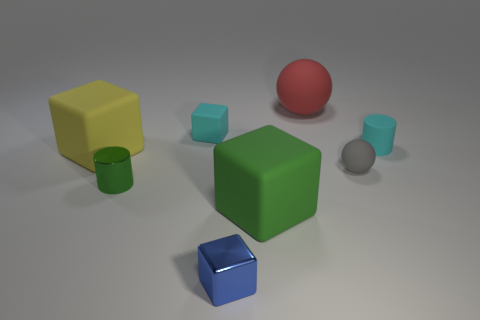Do the big matte sphere and the small metal cylinder have the same color?
Give a very brief answer. No. There is a yellow thing that is made of the same material as the big red thing; what shape is it?
Your answer should be very brief. Cube. There is a tiny matte object in front of the yellow cube; is its shape the same as the green matte object?
Your answer should be very brief. No. How many gray things are metal objects or metallic cubes?
Your answer should be very brief. 0. Are there an equal number of gray things that are left of the small shiny block and small metal things that are on the right side of the green matte cube?
Offer a very short reply. Yes. There is a matte block that is to the right of the small cyan rubber object left of the big rubber thing that is in front of the green cylinder; what color is it?
Your response must be concise. Green. Is there any other thing of the same color as the rubber cylinder?
Ensure brevity in your answer.  Yes. There is a tiny rubber object that is the same color as the small matte block; what shape is it?
Offer a very short reply. Cylinder. What is the size of the metal object that is behind the blue metallic object?
Your answer should be very brief. Small. The green object that is the same size as the yellow rubber block is what shape?
Provide a succinct answer. Cube. 